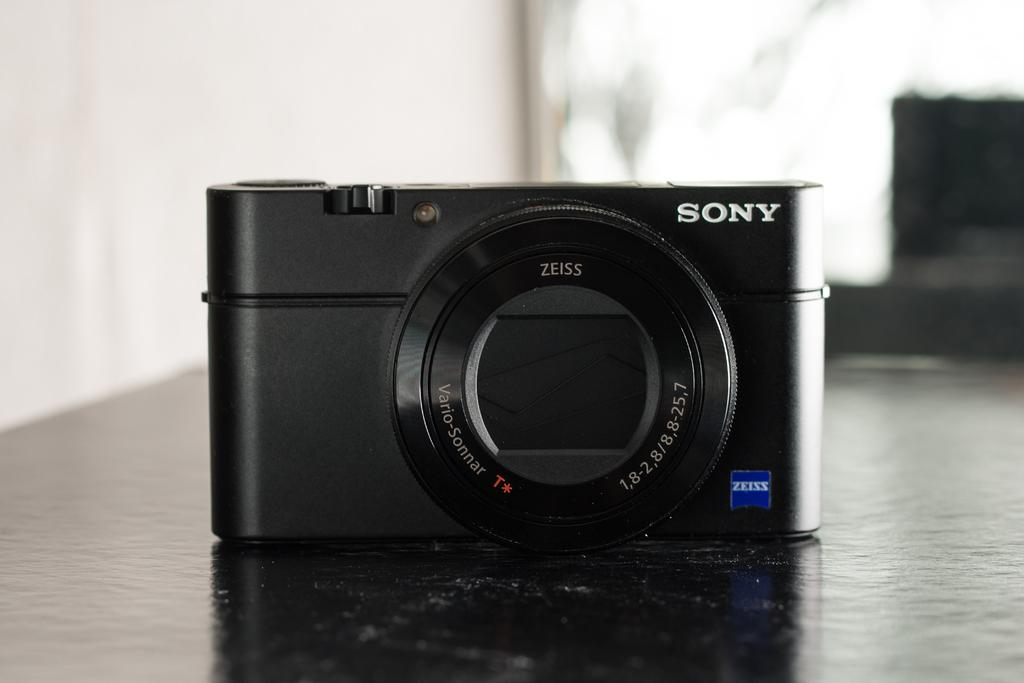<image>
Render a clear and concise summary of the photo. A black Sony camera on top of a black counter that says zeiss. 